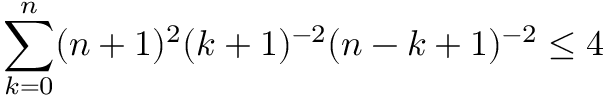Convert formula to latex. <formula><loc_0><loc_0><loc_500><loc_500>\sum _ { k = 0 } ^ { n } ( n + 1 ) ^ { 2 } ( k + 1 ) ^ { - 2 } ( n - k + 1 ) ^ { - 2 } \leq 4</formula> 